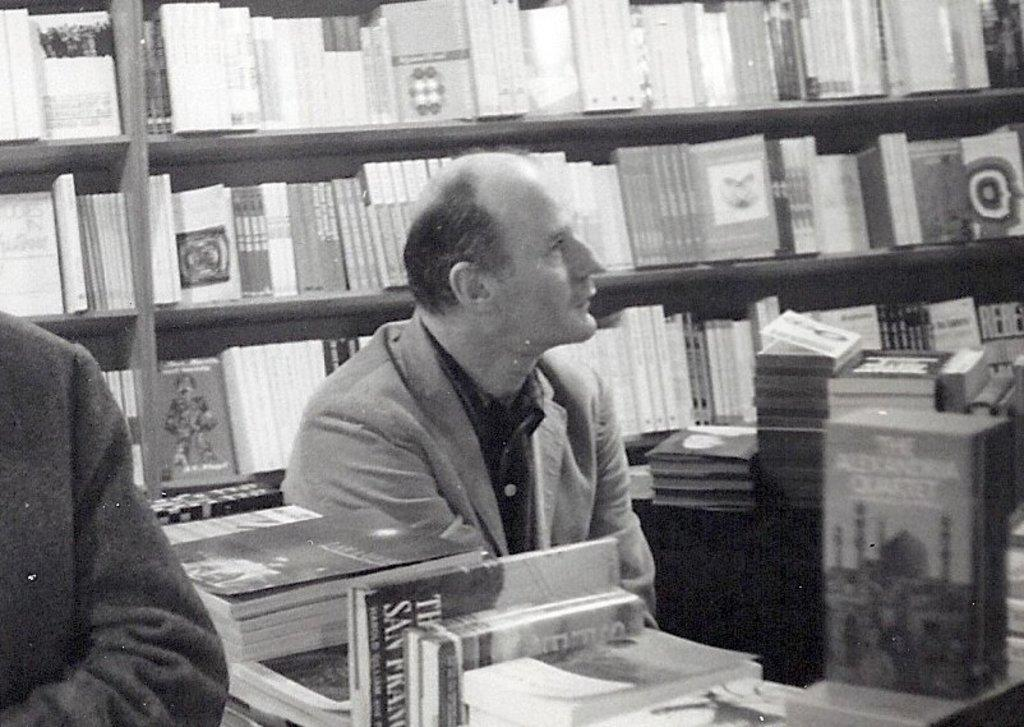What can be seen in the image? There are people in the image. What else is present in the image? There are racks filled with books in the image. What is the purpose of the people's debt in the image? There is no mention of debt in the image; it only features people and racks filled with books. How often do the people in the image get haircuts? There is no information about haircuts in the image; it only features people and racks filled with books. 